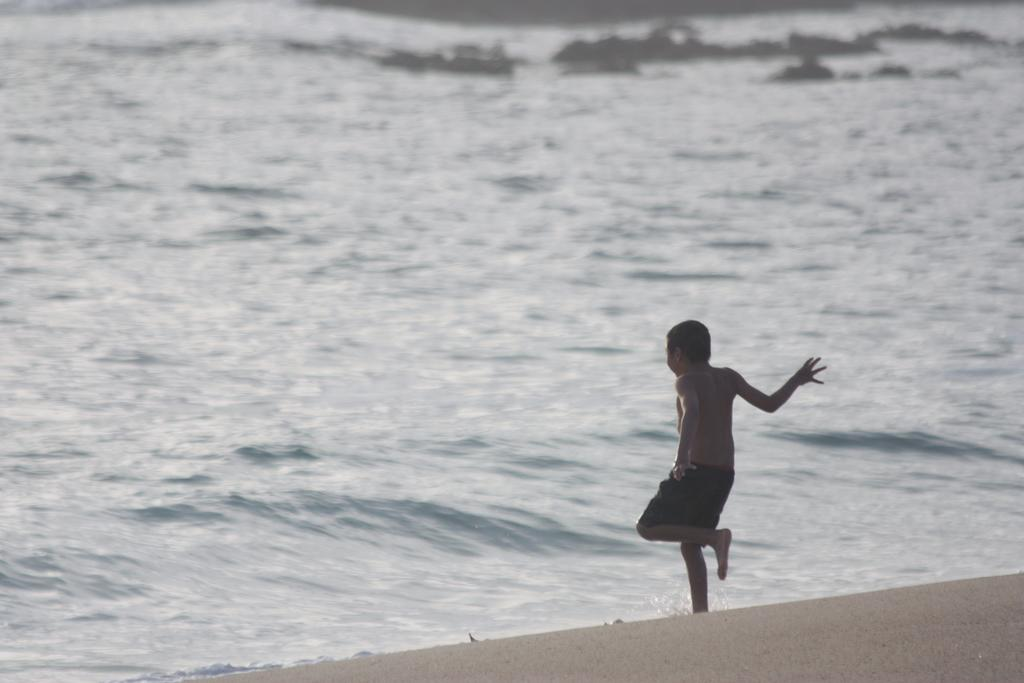Who is the main subject in the image? There is a boy in the center of the image. What is the boy doing in the image? The boy is walking into the water. What type of environment is visible in the background of the image? There is a beach in the background of the image. What is present at the bottom of the image? There is sand at the bottom of the image. What type of rose can be seen growing on the grass in the morning in the image? There is no rose or grass present in the image, and the time of day is not mentioned. 